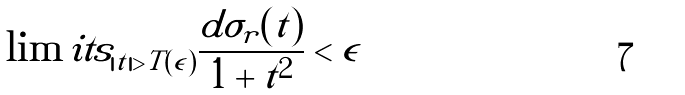<formula> <loc_0><loc_0><loc_500><loc_500>\int \lim i t s _ { | t | > T ( \epsilon ) } \frac { d \sigma _ { r } ( t ) } { 1 + t ^ { 2 } } < \epsilon</formula> 